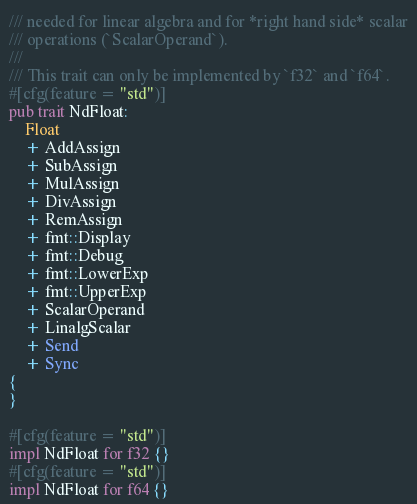<code> <loc_0><loc_0><loc_500><loc_500><_Rust_>/// needed for linear algebra and for *right hand side* scalar
/// operations (`ScalarOperand`).
///
/// This trait can only be implemented by `f32` and `f64`.
#[cfg(feature = "std")]
pub trait NdFloat:
    Float
    + AddAssign
    + SubAssign
    + MulAssign
    + DivAssign
    + RemAssign
    + fmt::Display
    + fmt::Debug
    + fmt::LowerExp
    + fmt::UpperExp
    + ScalarOperand
    + LinalgScalar
    + Send
    + Sync
{
}

#[cfg(feature = "std")]
impl NdFloat for f32 {}
#[cfg(feature = "std")]
impl NdFloat for f64 {}

</code> 